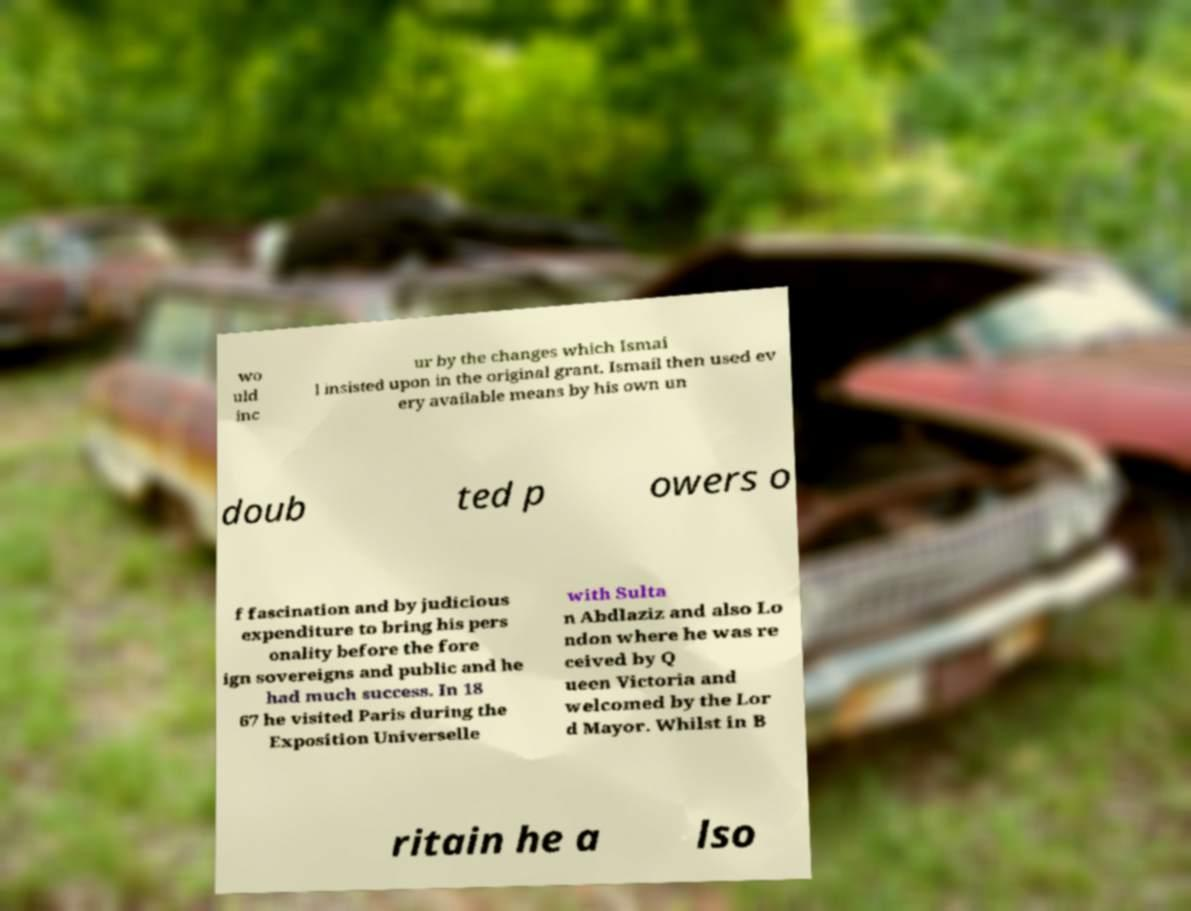Please read and relay the text visible in this image. What does it say? wo uld inc ur by the changes which Ismai l insisted upon in the original grant. Ismail then used ev ery available means by his own un doub ted p owers o f fascination and by judicious expenditure to bring his pers onality before the fore ign sovereigns and public and he had much success. In 18 67 he visited Paris during the Exposition Universelle with Sulta n Abdlaziz and also Lo ndon where he was re ceived by Q ueen Victoria and welcomed by the Lor d Mayor. Whilst in B ritain he a lso 